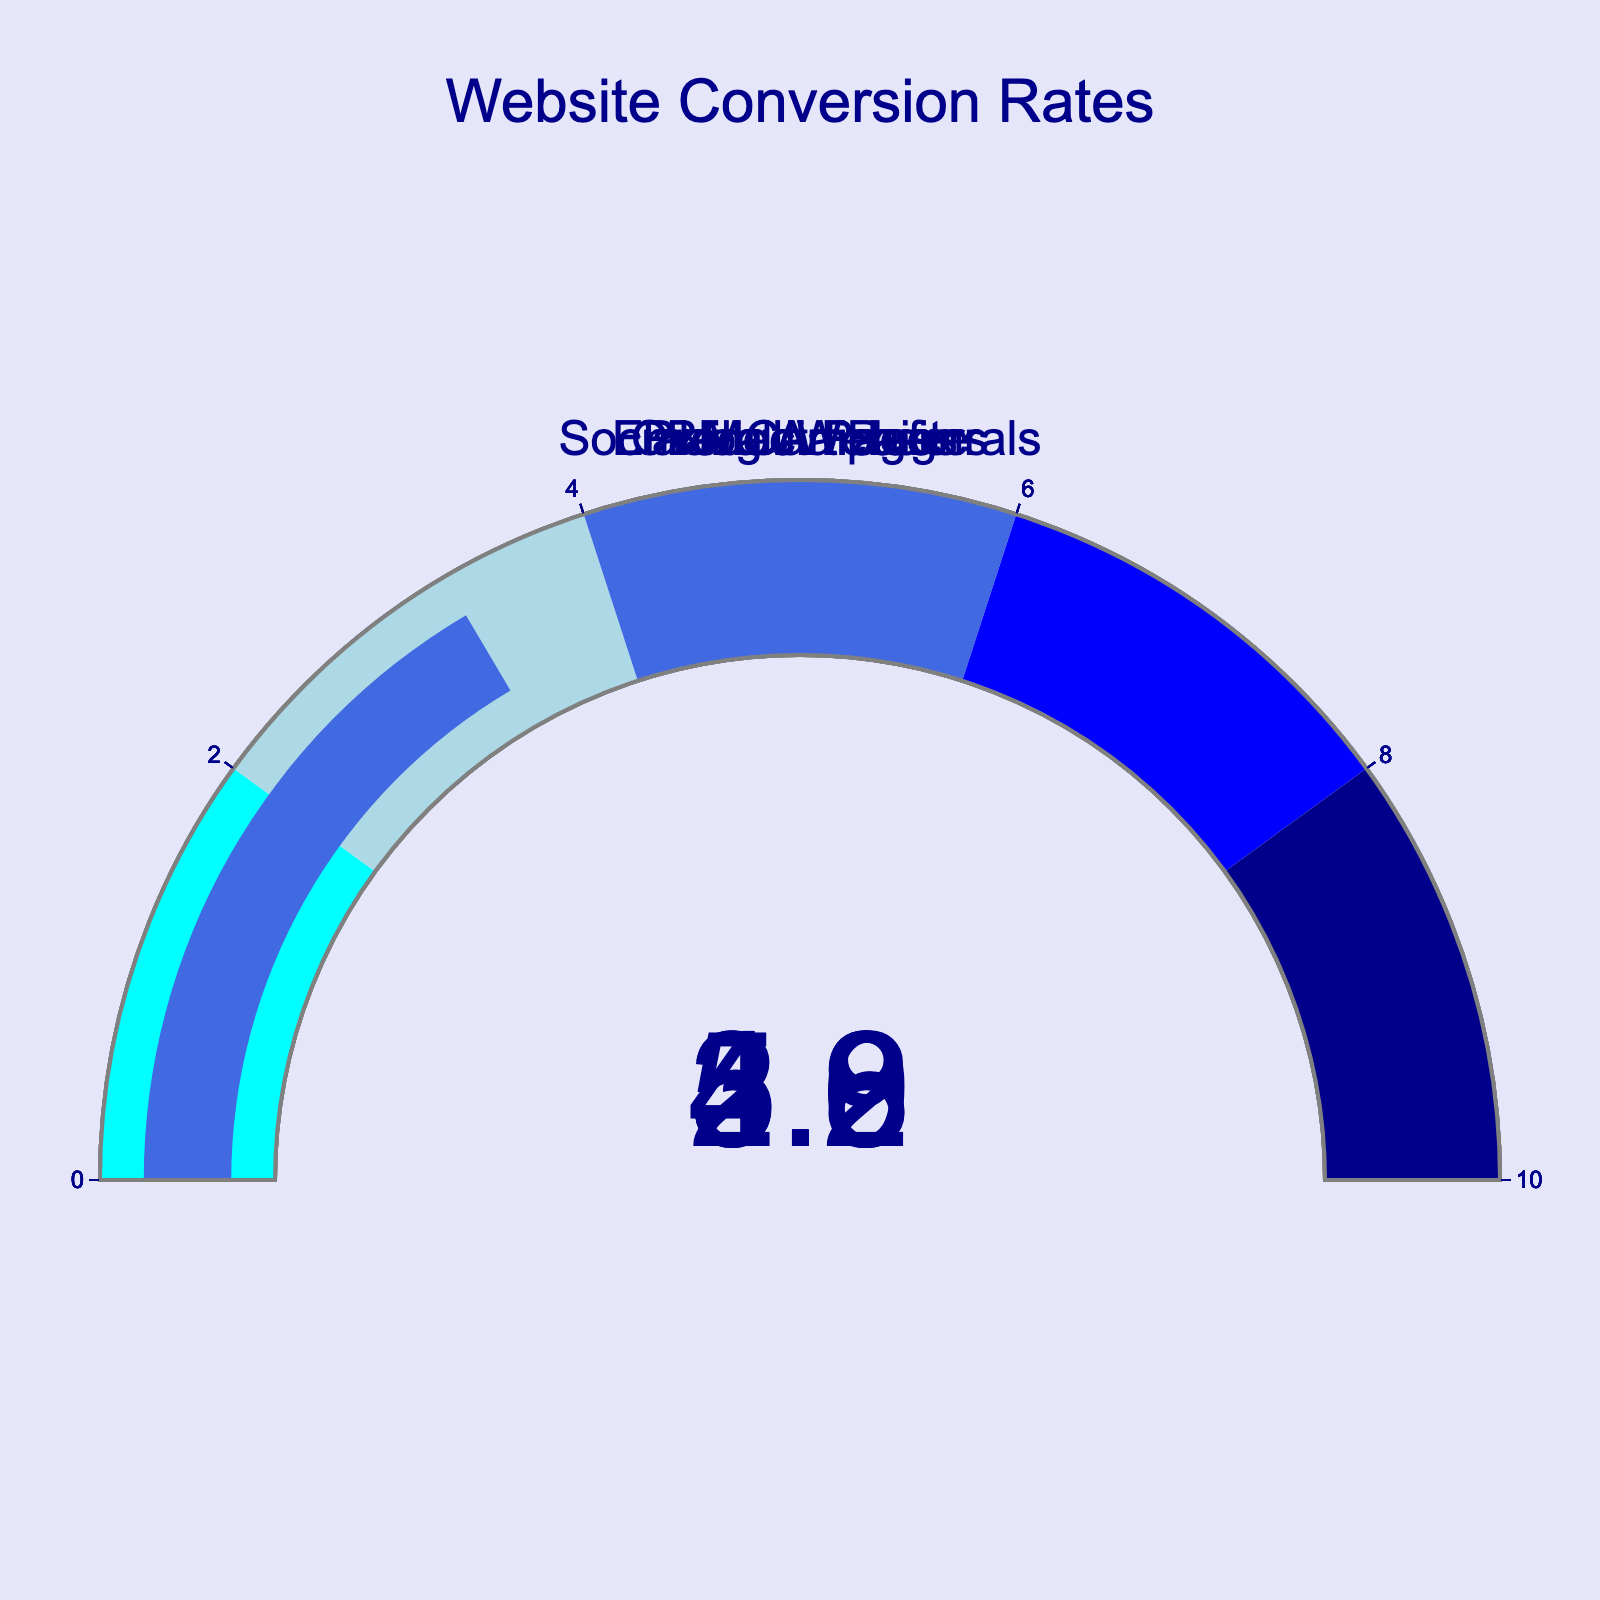What's the highest conversion rate displayed on the gauges? The highest conversion rate can be determined by looking at the values on each gauge and identifying the maximum value.
Answer: 5.2 Which gauge shows the lowest conversion rate? The lowest conversion rate is identified by comparing the values shown on each gauge and identifying the smallest value.
Answer: Blog Articles What is the average conversion rate across all categories? Add up the conversion rates and divide by the number of categories. (3.8 + 5.2 + 2.9 + 4.6 + 3.3) / 5 = 19.8 / 5
Answer: 3.96 What is the range of conversion rates displayed on the figure? Range is the difference between the highest and lowest values. Here, it's 5.2 (highest) - 2.9 (lowest) = 2.3.
Answer: 2.3 How much higher is the conversion rate of Product Pages compared to Social Media Referrals? Subtract the conversion rate of Social Media Referrals from Product Pages. 5.2 - 3.3 = 1.9
Answer: 1.9 Which category has a higher conversion rate, Email Campaigns or Overall Website? Compare the conversion rates of Email Campaigns (4.6) and Overall Website (3.8).
Answer: Email Campaigns What's the difference in conversion rate between the highest and lowest categories? Subtract the lowest conversion rate (2.9) from the highest conversion rate (5.2). 5.2 - 2.9 = 2.3
Answer: 2.3 What is the total conversion rate if all categories were combined? Sum all the conversion rates given in the figure. 3.8 + 5.2 + 2.9 + 4.6 + 3.3 = 19.8
Answer: 19.8 In which category does the conversion rate fall within the range of 4 to 6? Identify the categories that have conversion rates within this range. Only Product Pages (5.2) and Email Campaigns (4.6) fall within this range.
Answer: Product Pages, Email Campaigns How does the conversion rate of Blog Articles compare to Social Media Referrals in terms of percentage? Calculate the difference and then divide by the Social Media Referrals conversion rate. ((3.3 - 2.9) / 3.3) * 100 ≈ 12.1%
Answer: 12.1% 